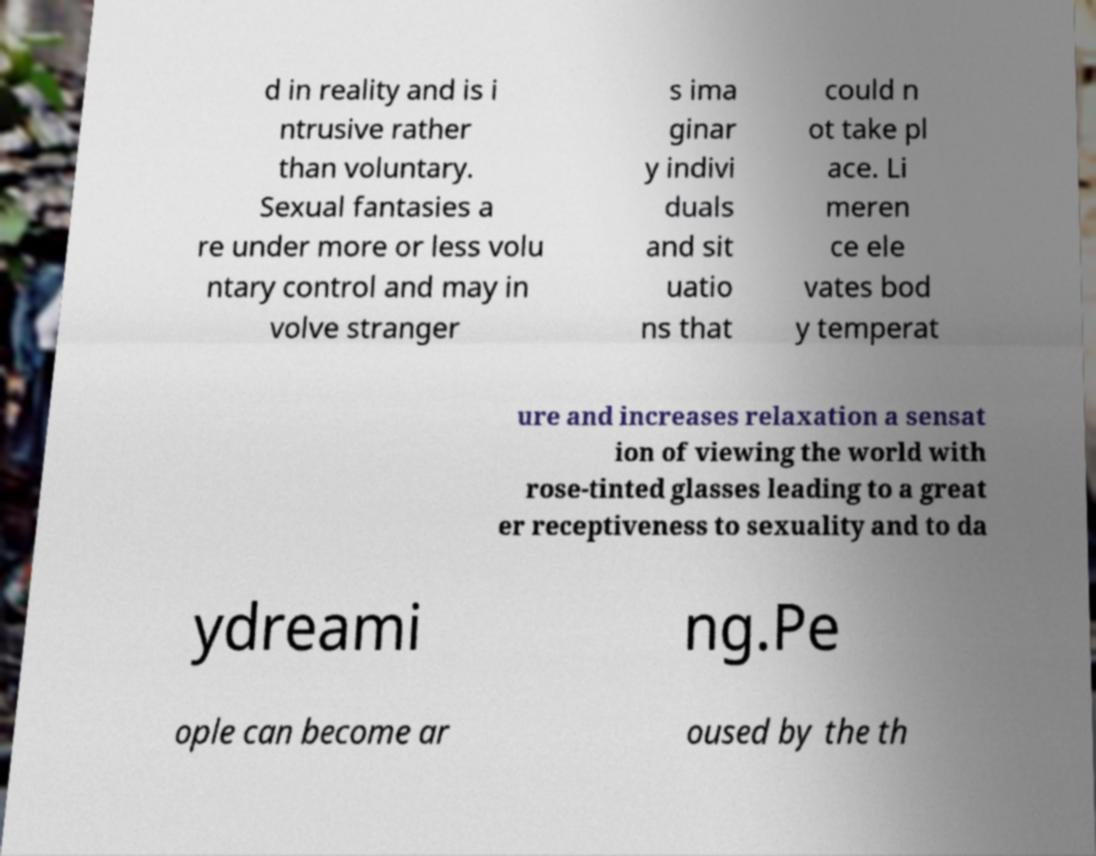I need the written content from this picture converted into text. Can you do that? d in reality and is i ntrusive rather than voluntary. Sexual fantasies a re under more or less volu ntary control and may in volve stranger s ima ginar y indivi duals and sit uatio ns that could n ot take pl ace. Li meren ce ele vates bod y temperat ure and increases relaxation a sensat ion of viewing the world with rose-tinted glasses leading to a great er receptiveness to sexuality and to da ydreami ng.Pe ople can become ar oused by the th 